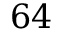Convert formula to latex. <formula><loc_0><loc_0><loc_500><loc_500>6 4</formula> 